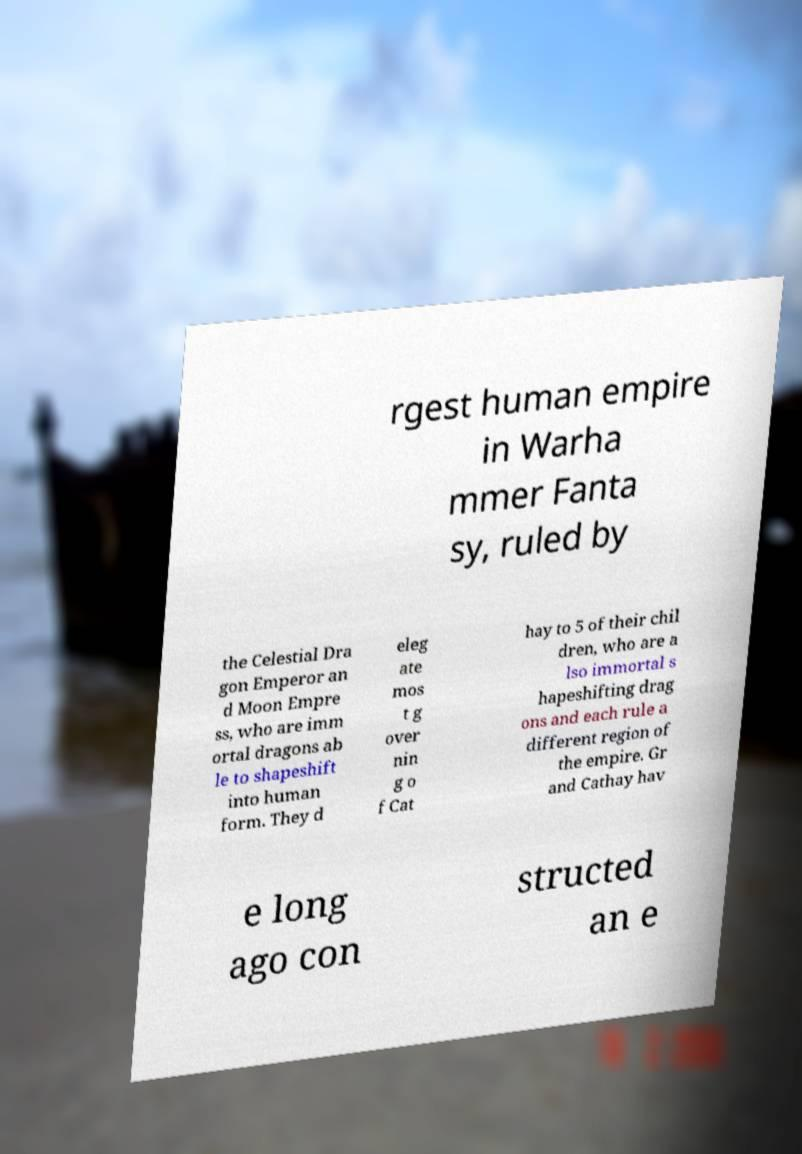Could you extract and type out the text from this image? rgest human empire in Warha mmer Fanta sy, ruled by the Celestial Dra gon Emperor an d Moon Empre ss, who are imm ortal dragons ab le to shapeshift into human form. They d eleg ate mos t g over nin g o f Cat hay to 5 of their chil dren, who are a lso immortal s hapeshifting drag ons and each rule a different region of the empire. Gr and Cathay hav e long ago con structed an e 